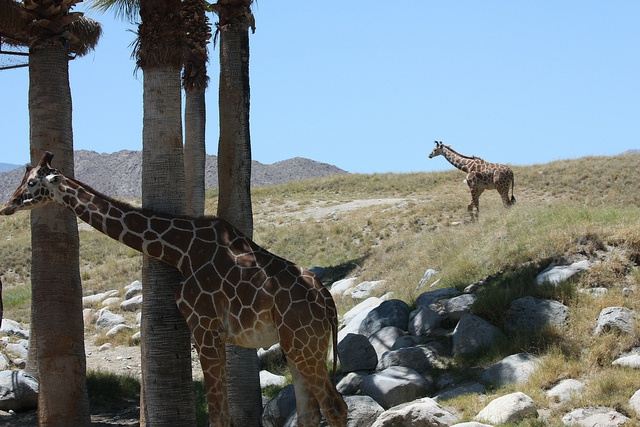Describe the objects in this image and their specific colors. I can see giraffe in black and gray tones and giraffe in black, gray, and darkgray tones in this image. 